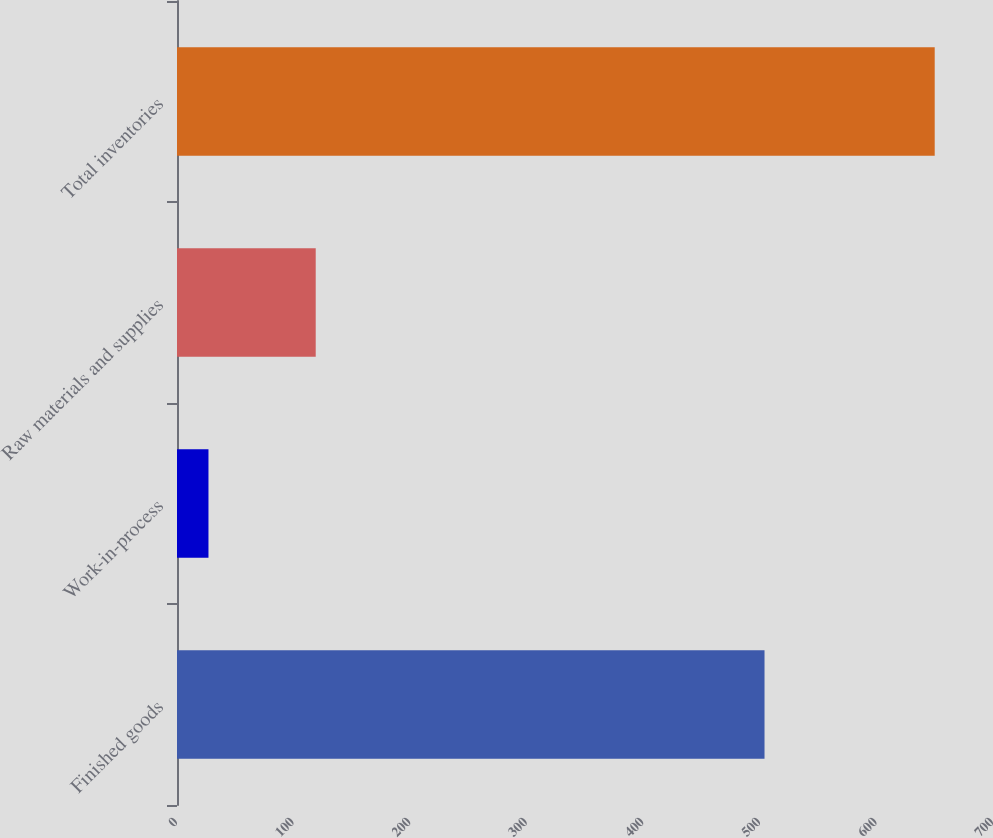<chart> <loc_0><loc_0><loc_500><loc_500><bar_chart><fcel>Finished goods<fcel>Work-in-process<fcel>Raw materials and supplies<fcel>Total inventories<nl><fcel>504<fcel>27<fcel>119<fcel>650<nl></chart> 